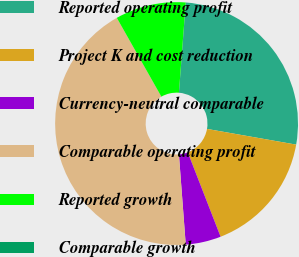Convert chart. <chart><loc_0><loc_0><loc_500><loc_500><pie_chart><fcel>Reported operating profit<fcel>Project K and cost reduction<fcel>Currency-neutral comparable<fcel>Comparable operating profit<fcel>Reported growth<fcel>Comparable growth<nl><fcel>26.56%<fcel>16.32%<fcel>4.7%<fcel>43.01%<fcel>9.39%<fcel>0.01%<nl></chart> 